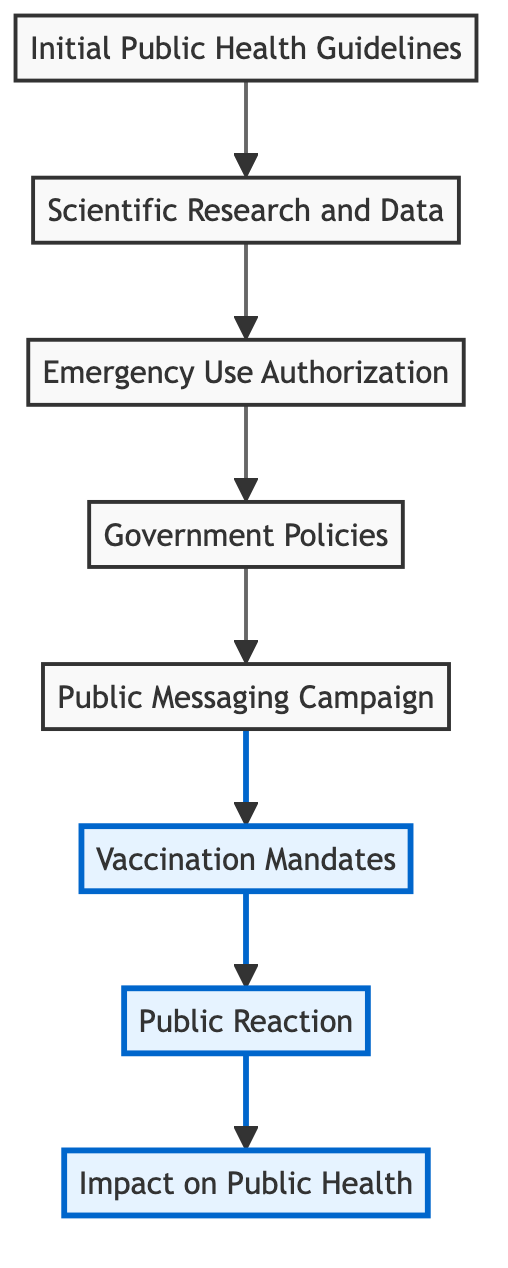What is the first step in the flow chart? The first step in the flow chart is "Initial Public Health Guidelines," which is the bottom node in the diagram.
Answer: Initial Public Health Guidelines How many elements are in the flow chart? Counting all the nodes from the bottom to the top, there are eight elements in total.
Answer: Eight What follows "Emergency Use Authorization" in the flow chart? The flow follows from "Emergency Use Authorization" to "Government Policies," which is the next node up in the diagram.
Answer: Government Policies Which nodes in the flow chart are highlighted? The highlighted nodes include "Vaccination Mandates," "Public Reaction," and "Impact on Public Health," indicating their significance in the flow.
Answer: Vaccination Mandates, Public Reaction, Impact on Public Health What is the relationship between "Public Messaging Campaign" and "Vaccination Mandates"? The relationship is that "Public Messaging Campaign" leads directly to "Vaccination Mandates," meaning the messaging supports and influences the implementation of mandates.
Answer: Leads to What is the significance of the highlighted nodes compared to the others? The highlighted nodes represent crucial stages in the journey from guidelines to public health impact, showing where attention is particularly warranted in understanding public health responses.
Answer: Crucial stages Which government policies are prioritized according to the diagram? According to the diagram, government policies prioritize frontline workers, the elderly, and high-risk populations for vaccine distribution.
Answer: Frontline workers, elderly, high-risk populations What is the ultimate impact of vaccinations highlighted in the flow chart? The ultimate impact of vaccinations that is highlighted is measured through metrics such as reduced transmission rates and hospitalizations, displaying the effectiveness of vaccines.
Answer: Reduced transmission rates and hospitalizations What flows immediately after "Public Reaction"? Immediately after "Public Reaction," the flow continues to "Impact on Public Health," indicating that public reactions influence the overall public health metrics reported.
Answer: Impact on Public Health 